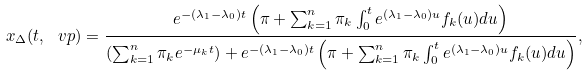<formula> <loc_0><loc_0><loc_500><loc_500>x _ { \Delta } ( t , \ v p ) = \frac { e ^ { - ( \lambda _ { 1 } - \lambda _ { 0 } ) t } \left ( \pi + \sum _ { k = 1 } ^ { n } \pi _ { k } \int _ { 0 } ^ { t } e ^ { ( \lambda _ { 1 } - \lambda _ { 0 } ) u } f _ { k } ( u ) d u \right ) } { \left ( \sum _ { k = 1 } ^ { n } \pi _ { k } e ^ { - \mu _ { k } t } \right ) + e ^ { - ( \lambda _ { 1 } - \lambda _ { 0 } ) t } \left ( \pi + \sum _ { k = 1 } ^ { n } \pi _ { k } \int _ { 0 } ^ { t } e ^ { ( \lambda _ { 1 } - \lambda _ { 0 } ) u } f _ { k } ( u ) d u \right ) } ,</formula> 